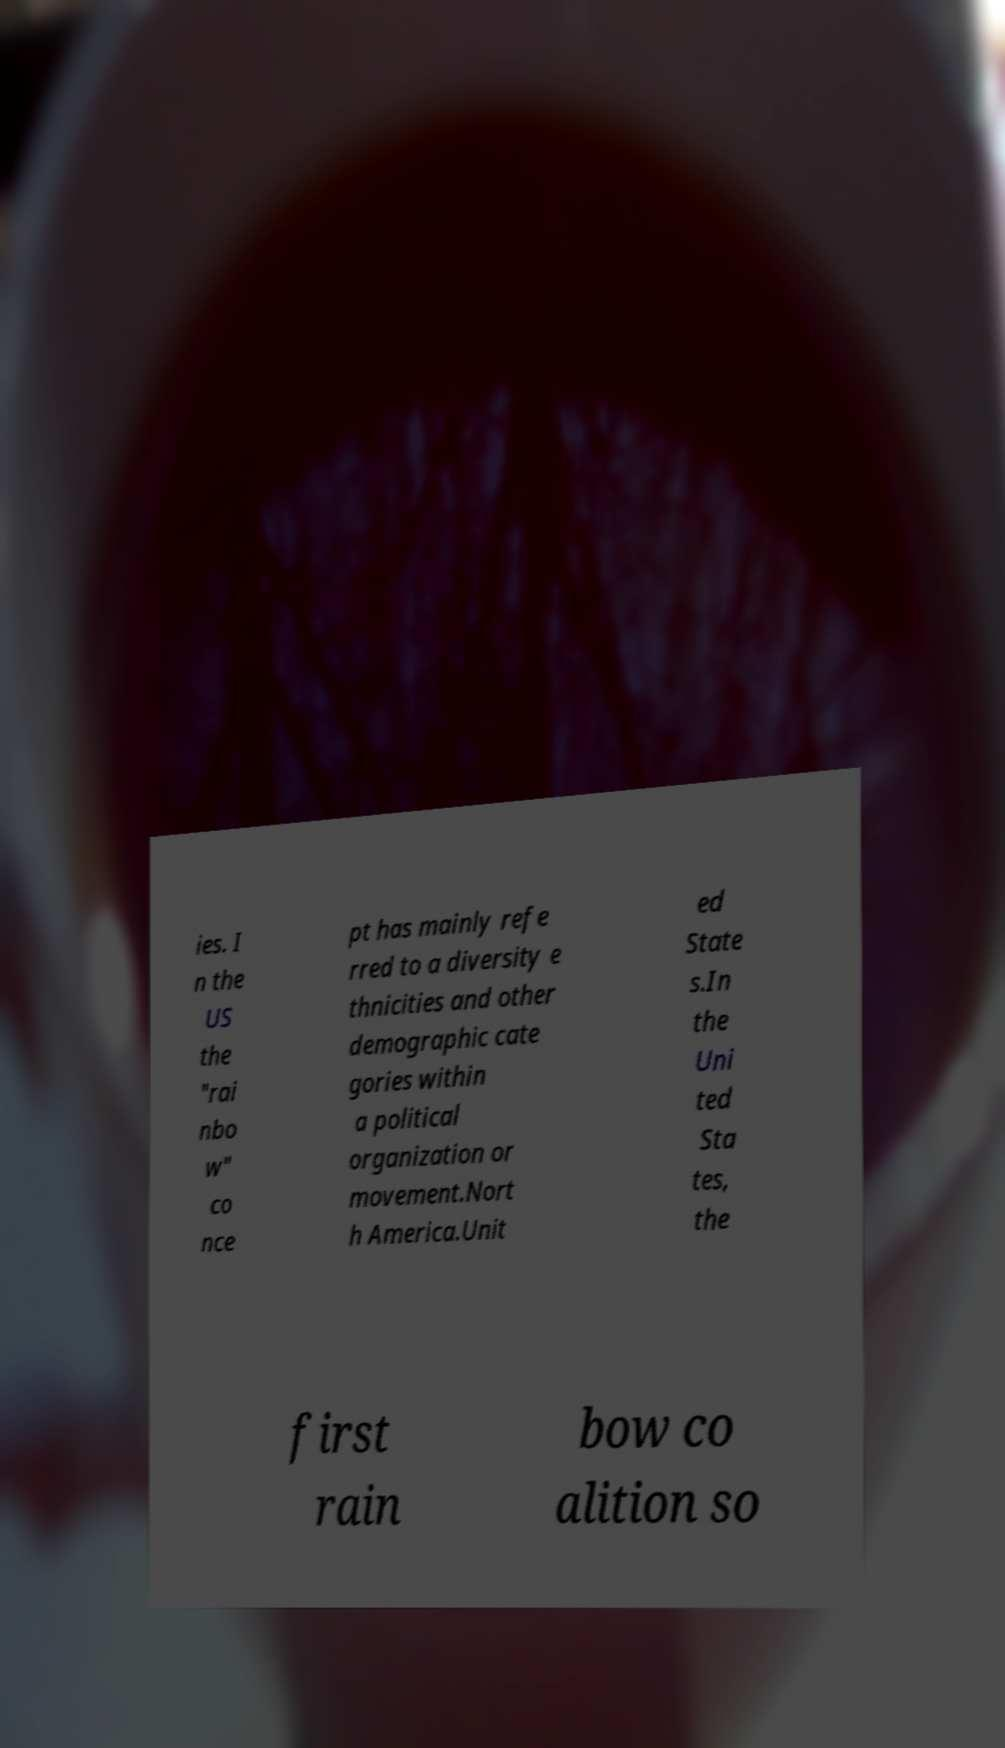What messages or text are displayed in this image? I need them in a readable, typed format. ies. I n the US the "rai nbo w" co nce pt has mainly refe rred to a diversity e thnicities and other demographic cate gories within a political organization or movement.Nort h America.Unit ed State s.In the Uni ted Sta tes, the first rain bow co alition so 